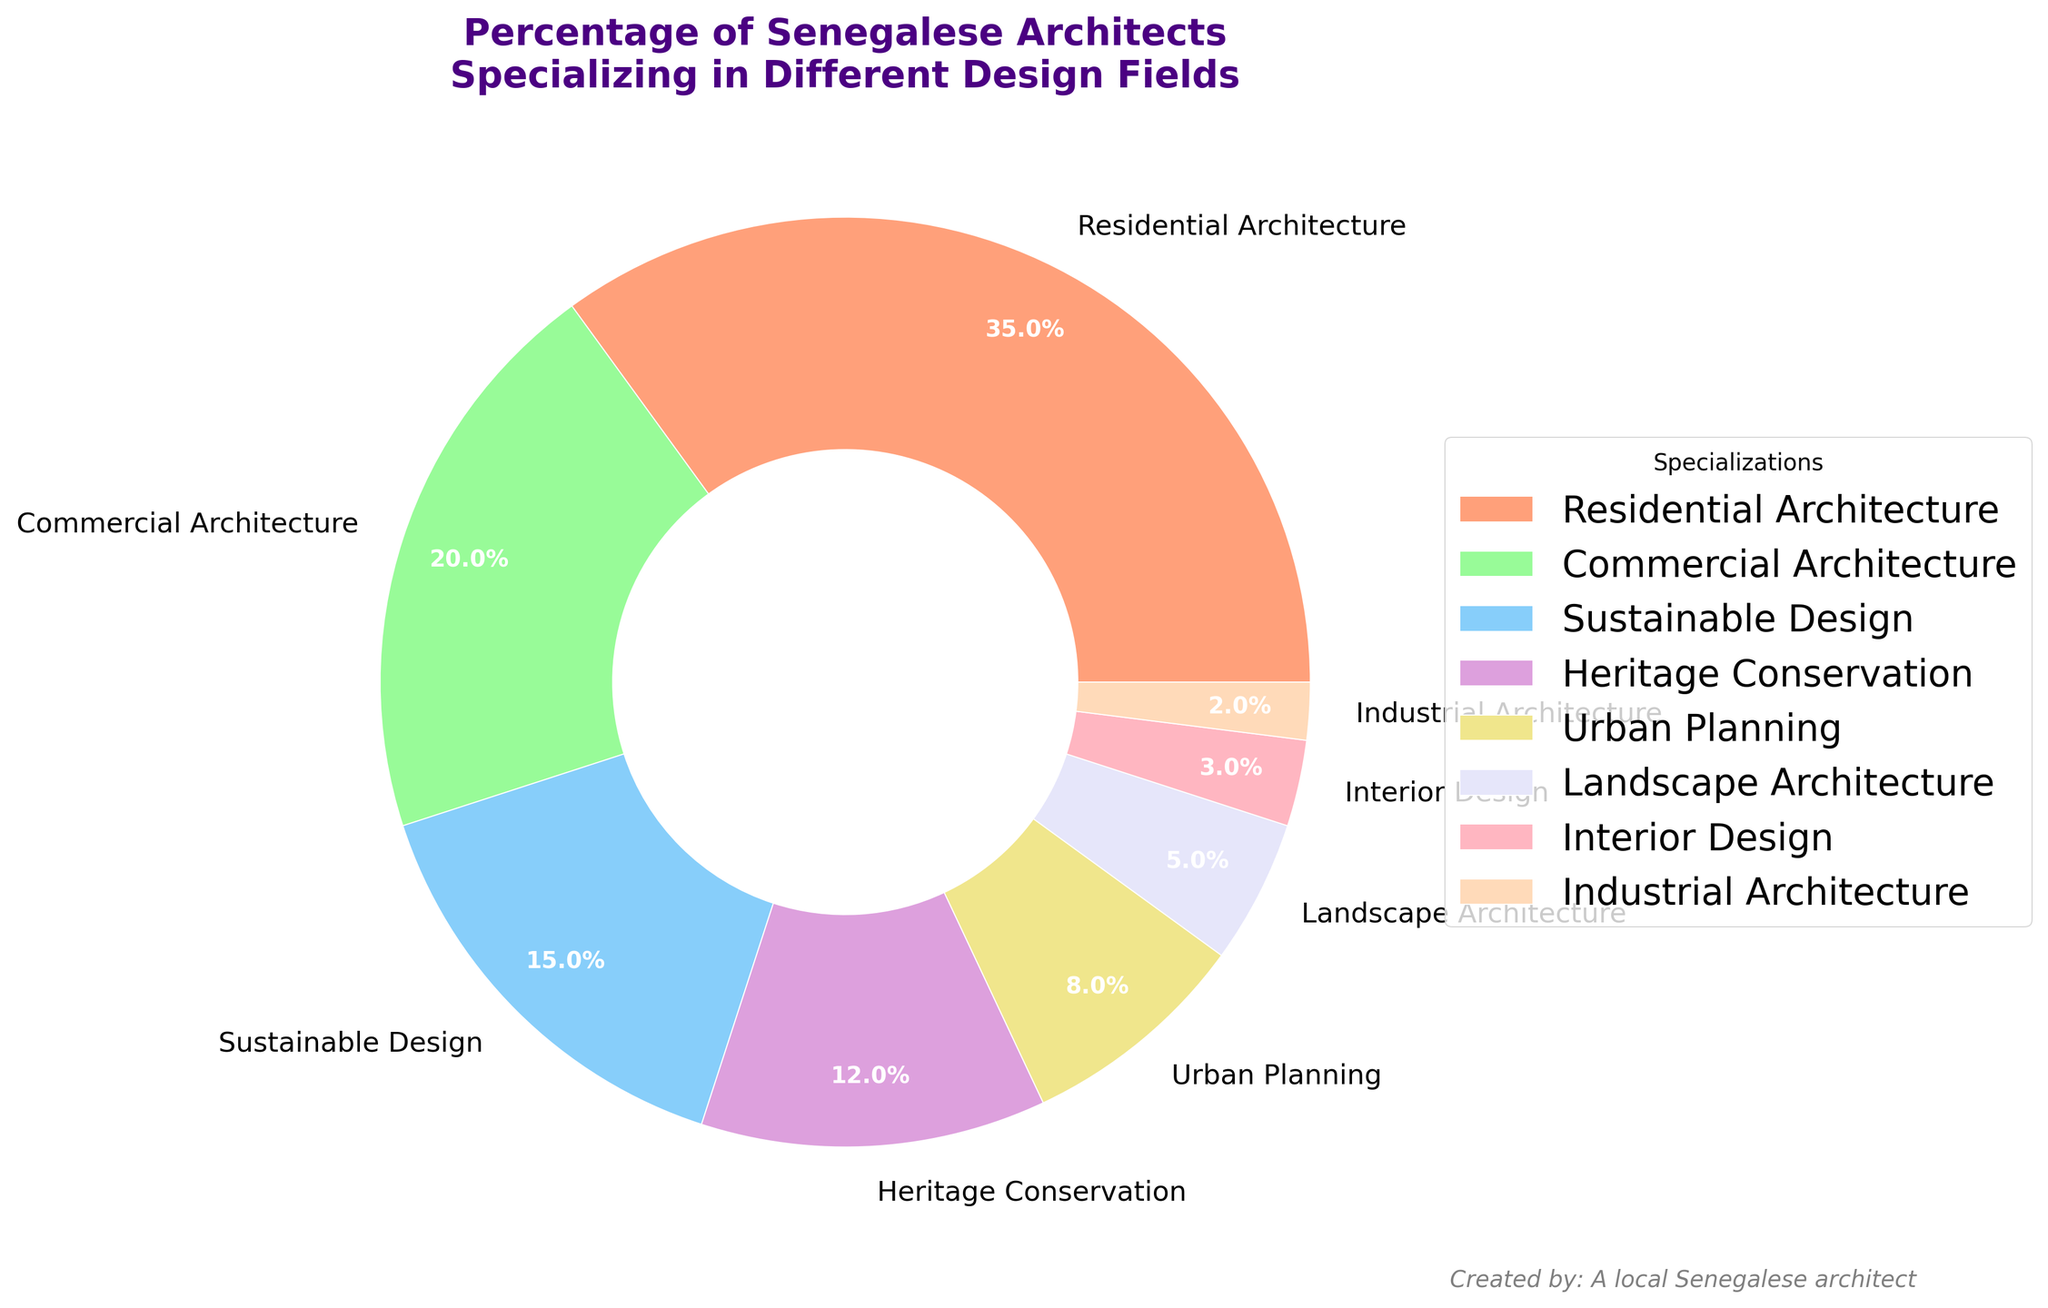What is the most common specialization among Senegalese architects? The largest segment on the pie chart represents "Residential Architecture" with 35%. Hence, it is the most common specialization.
Answer: Residential Architecture How many architects specialize in Sustainable Design compared to Urban Planning? Sustainable Design makes up 15% of the chart while Urban Planning accounts for 8%. Therefore, there are more architects specializing in Sustainable Design.
Answer: Sustainable Design What percentage of Senegalese architects specialize in Heritage Conservation plus Urban Planning? Heritage Conservation makes up 12% and Urban Planning makes up 8%. Adding these together gives 12% + 8% = 20%.
Answer: 20% Which is greater: the percentage of architects in Commercial Architecture or Heritage Conservation? Commercial Architecture accounts for 20% and Heritage Conservation for 12%. Comparatively, Commercial Architecture is greater.
Answer: Commercial Architecture What is the total percentage of architects in non-residential specializations combined? Adding percentages for Commercial Architecture, Sustainable Design, Heritage Conservation, Urban Planning, Landscape Architecture, Interior Design, and Industrial Architecture: 20% + 15% + 12% + 8% + 5% + 3% + 2% = 65%.
Answer: 65% Describe the color and percentage for Landscape Architecture. The segment for Landscape Architecture is colored in a pastel lavender shade and represents 5% of the chart as labeled.
Answer: Pastel lavender, 5% What is the smallest specialization category in terms of percentage? The smallest segment on the pie chart represents "Industrial Architecture" with 2%.
Answer: Industrial Architecture What is the combined percentage of architects specializing in Residential Architecture, Commercial Architecture, and Sustainable Design? Summing these percentages: 35% (Residential Architecture) + 20% (Commercial Architecture) + 15% (Sustainable Design) = 70%.
Answer: 70% 